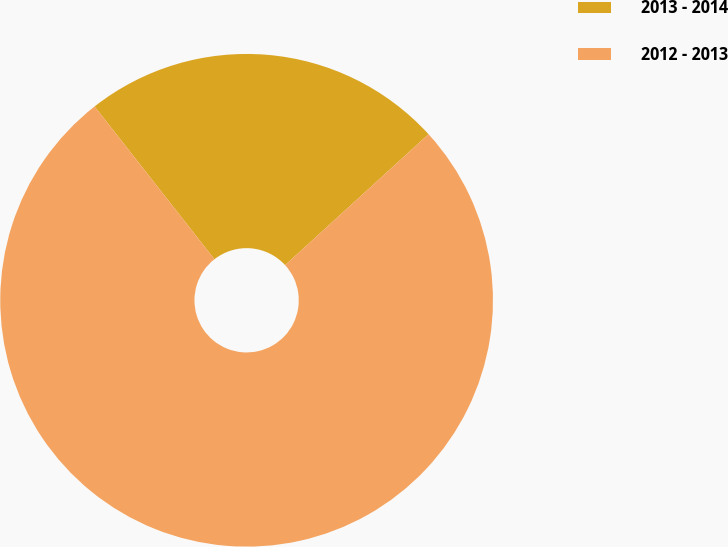<chart> <loc_0><loc_0><loc_500><loc_500><pie_chart><fcel>2013 - 2014<fcel>2012 - 2013<nl><fcel>23.81%<fcel>76.19%<nl></chart> 